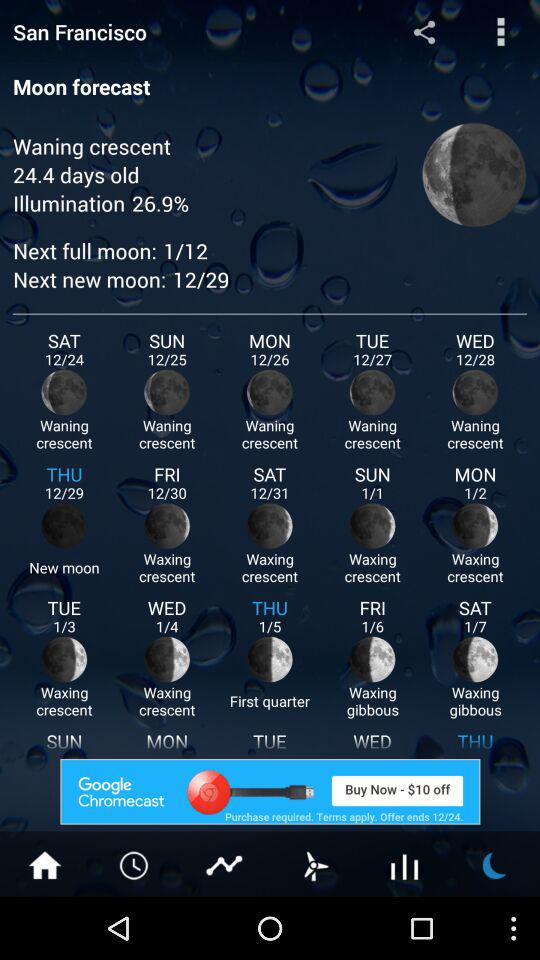What is the date of the first quarter of the moon? The date of the first quarter of the moon is January 5. 